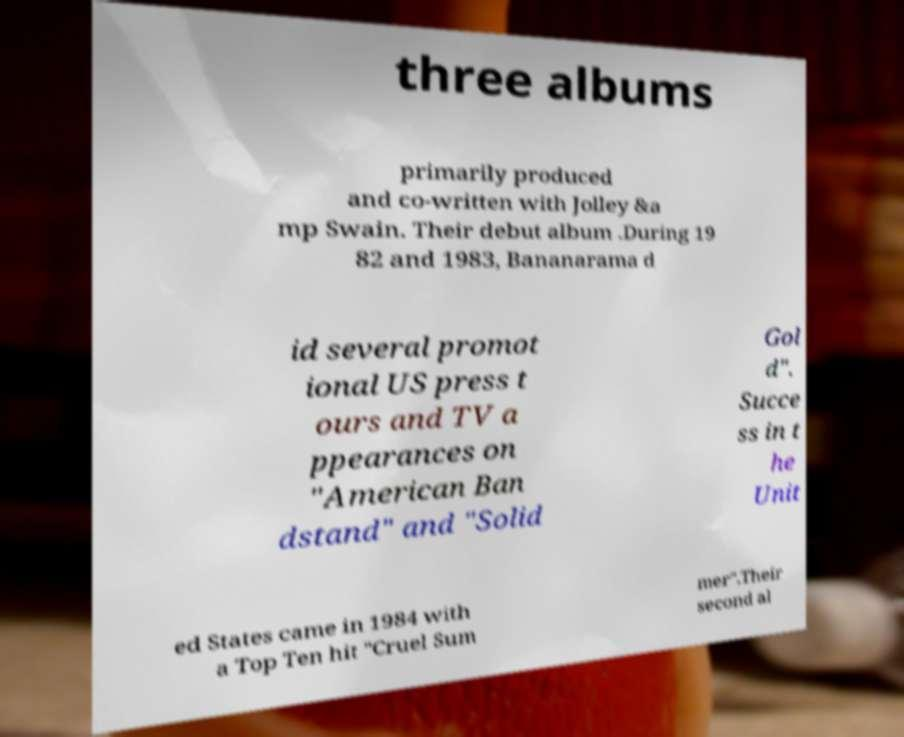For documentation purposes, I need the text within this image transcribed. Could you provide that? three albums primarily produced and co-written with Jolley &a mp Swain. Their debut album .During 19 82 and 1983, Bananarama d id several promot ional US press t ours and TV a ppearances on "American Ban dstand" and "Solid Gol d". Succe ss in t he Unit ed States came in 1984 with a Top Ten hit "Cruel Sum mer".Their second al 